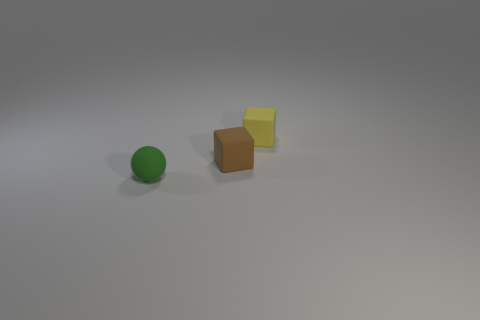Add 3 small brown rubber things. How many objects exist? 6 Subtract all tiny yellow rubber objects. Subtract all brown rubber blocks. How many objects are left? 1 Add 2 matte things. How many matte things are left? 5 Add 2 balls. How many balls exist? 3 Subtract 0 blue blocks. How many objects are left? 3 Subtract all spheres. How many objects are left? 2 Subtract all cyan blocks. Subtract all green cylinders. How many blocks are left? 2 